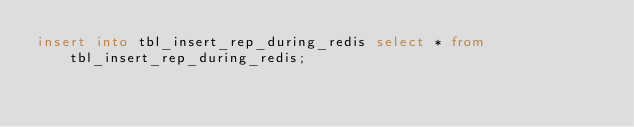Convert code to text. <code><loc_0><loc_0><loc_500><loc_500><_SQL_>insert into tbl_insert_rep_during_redis select * from tbl_insert_rep_during_redis;
</code> 